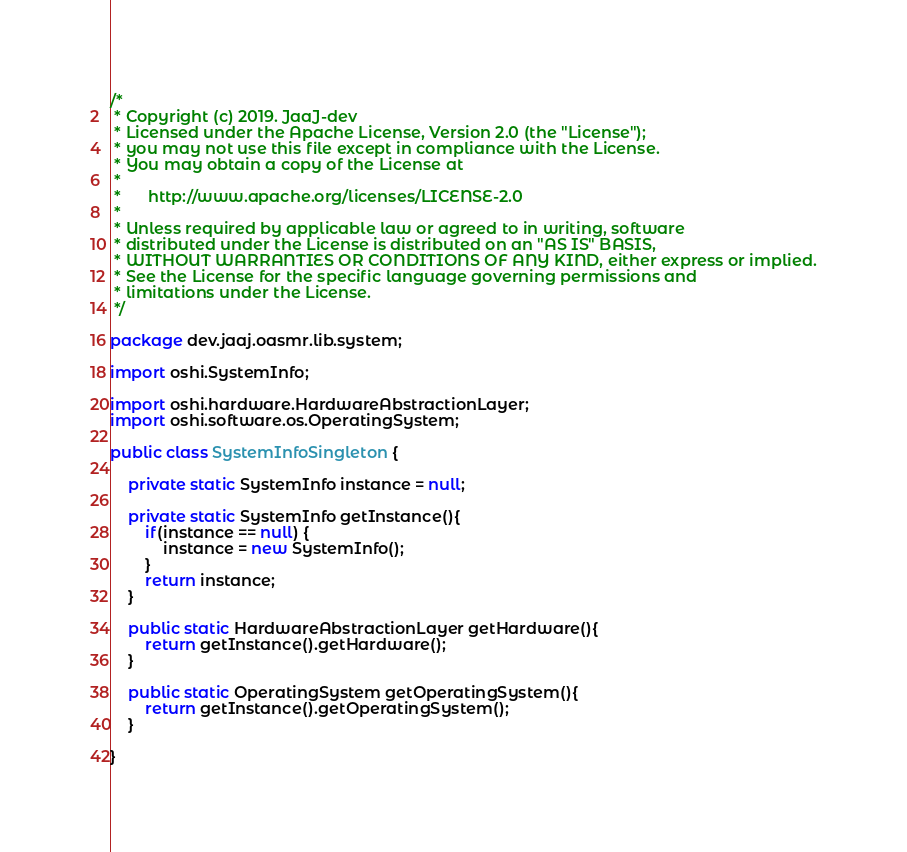<code> <loc_0><loc_0><loc_500><loc_500><_Java_>/*
 * Copyright (c) 2019. JaaJ-dev
 * Licensed under the Apache License, Version 2.0 (the "License");
 * you may not use this file except in compliance with the License.
 * You may obtain a copy of the License at
 *
 *      http://www.apache.org/licenses/LICENSE-2.0
 *
 * Unless required by applicable law or agreed to in writing, software
 * distributed under the License is distributed on an "AS IS" BASIS,
 * WITHOUT WARRANTIES OR CONDITIONS OF ANY KIND, either express or implied.
 * See the License for the specific language governing permissions and
 * limitations under the License.
 */

package dev.jaaj.oasmr.lib.system;

import oshi.SystemInfo;

import oshi.hardware.HardwareAbstractionLayer;
import oshi.software.os.OperatingSystem;

public class SystemInfoSingleton {

    private static SystemInfo instance = null;

    private static SystemInfo getInstance(){
        if(instance == null) {
            instance = new SystemInfo();
        }
        return instance;
    }

    public static HardwareAbstractionLayer getHardware(){
        return getInstance().getHardware();
    }

    public static OperatingSystem getOperatingSystem(){
        return getInstance().getOperatingSystem();
    }

}
</code> 